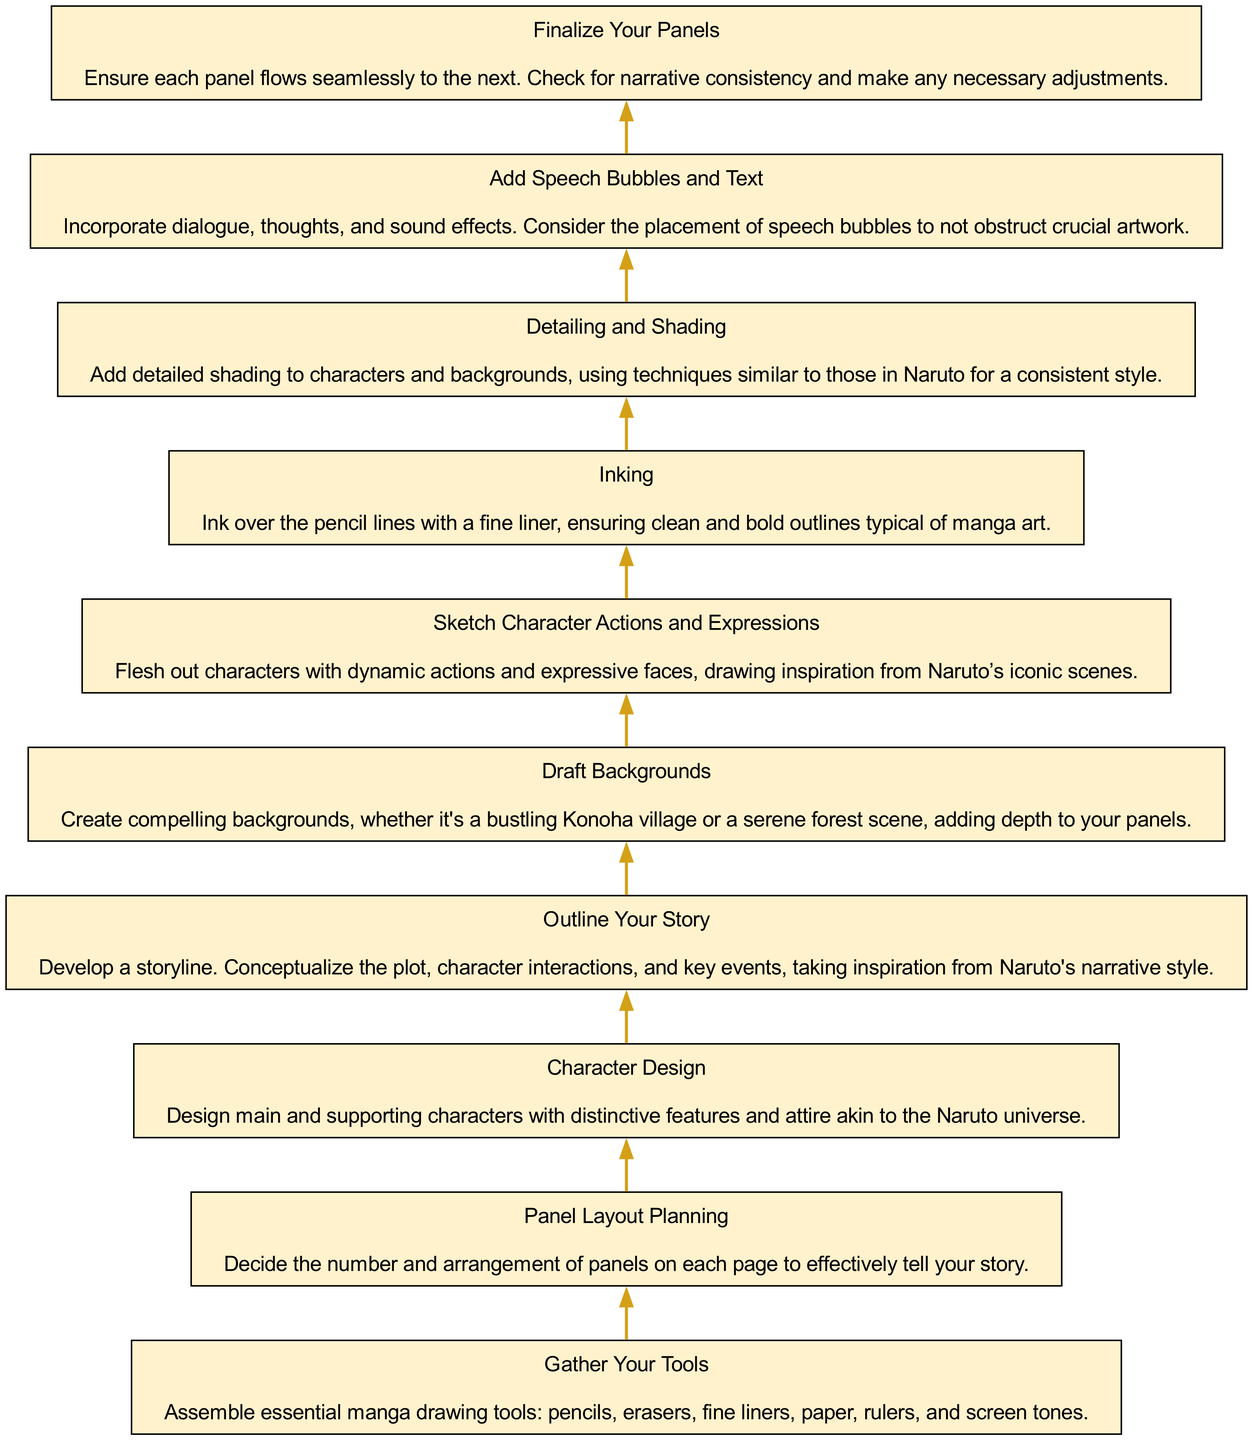What is the final step in the diagram? The final step at the top of the diagram is labeled "Finalize Your Panels," which is the concluding action in the flow of creating manga panels.
Answer: Finalize Your Panels How many steps are in the diagram? By counting each distinct step from "Gather Your Tools" to "Finalize Your Panels," we find a total of 10 steps listed in the diagram.
Answer: 10 What step comes before 'Detailing and Shading'? The step directly below 'Detailing and Shading' is 'Inking,' indicating the order in which actions should be taken while drawing manga panels.
Answer: Inking What type of tools are gathered as the first step? The first step in the flow is to 'Gather Your Tools,' and it specifically mentions assembling necessary manga drawing tools like pencils and fine liners.
Answer: Tools Which step involves designing characters? The step titled 'Character Design' specifically involves creating the main and supporting characters with features akin to those in Naruto, thus addressing character design explicitly.
Answer: Character Design What is the relationship between 'Outline Your Story' and 'Sketch Character Actions and Expressions'? 'Outline Your Story' is a preceding step that logically sets the stage for 'Sketch Character Actions and Expressions,' meaning you need to have a storyline before you can sketch the characters' actions and expressions.
Answer: Preceding step Which step addresses background creation? The step 'Draft Backgrounds' is directly concerned with creating environments for the manga panels, emphasizing the need for compelling backgrounds.
Answer: Draft Backgrounds At what point should speech bubbles and text be added? According to the flow, the 'Add Speech Bubbles and Text' step follows after 'Detailing and Shading,' indicating that dialogue is inserted after the visual elements are more finalized.
Answer: After detailing and shading What is the emphasis of the 'Panel Layout Planning' step? The 'Panel Layout Planning' step emphasizes deciding on the arrangement of panels to effectively tell the story visually, showing the importance of layout in manga storytelling.
Answer: Arranging panels 